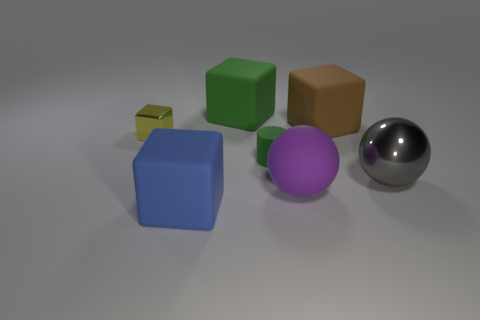There is a matte cube in front of the small rubber cylinder; is its color the same as the tiny rubber cylinder?
Provide a succinct answer. No. There is a metallic object that is in front of the small green cylinder; what color is it?
Offer a terse response. Gray. How many large things are yellow objects or green rubber cylinders?
Your answer should be compact. 0. Does the metallic thing right of the small yellow thing have the same color as the matte cube in front of the large gray thing?
Make the answer very short. No. How many other objects are the same color as the tiny cube?
Your answer should be compact. 0. How many gray objects are either big matte things or big matte balls?
Provide a succinct answer. 0. Do the big purple object and the green rubber object right of the big green rubber cube have the same shape?
Provide a short and direct response. No. There is a purple rubber object; what shape is it?
Give a very brief answer. Sphere. There is a blue block that is the same size as the gray metallic object; what is it made of?
Your answer should be very brief. Rubber. Is there anything else that is the same size as the brown rubber block?
Your answer should be compact. Yes. 